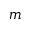<formula> <loc_0><loc_0><loc_500><loc_500>m</formula> 